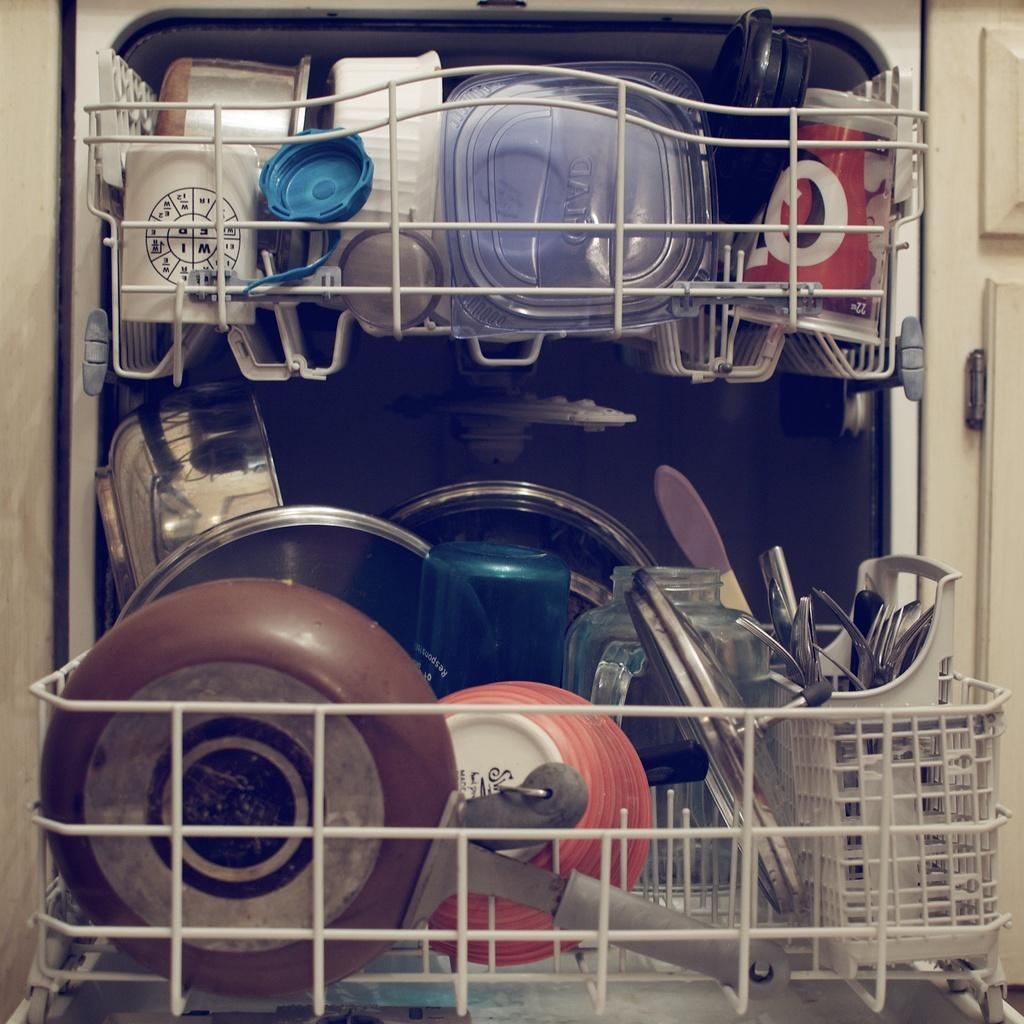What type of rack is in the image? There is a steel rack in the image. What kitchen items can be seen in the rack? A frying pan, bowls, a glass jar, a cup, boxes, serving spoons, and other utensils are visible in the rack. Can you describe the door in the image? There is a door in the image, but its specific characteristics are not mentioned in the provided facts. How many bikes are locked up outside the door in the image? There is no mention of bikes or any locking mechanism in the image, so it is not possible to answer this question. 